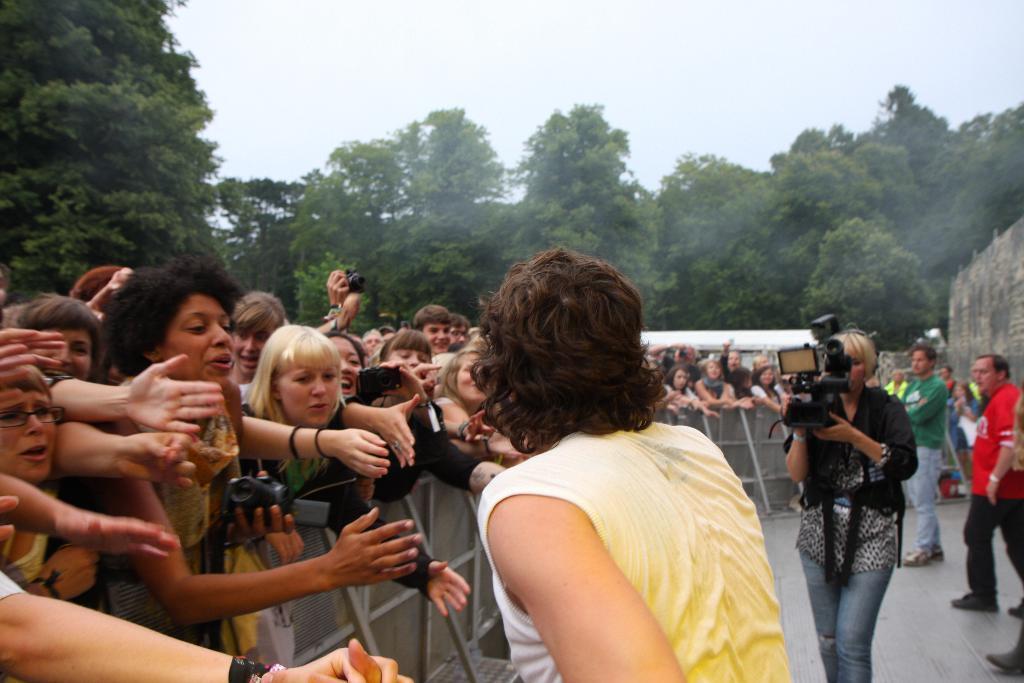How would you summarize this image in a sentence or two? In this image, we can see a group of people are standing near the fencing. Few are holding cameras. Background we can see trees, wall, tent. Top of the image, there is a sky. 